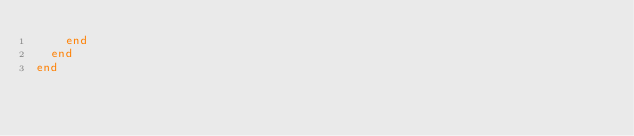<code> <loc_0><loc_0><loc_500><loc_500><_Ruby_>    end
  end
end
</code> 